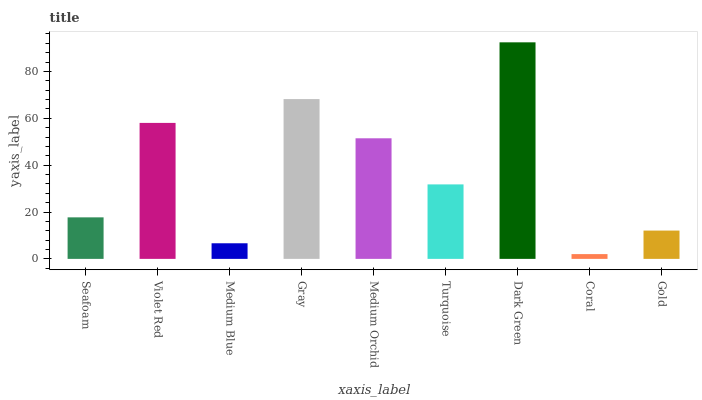Is Violet Red the minimum?
Answer yes or no. No. Is Violet Red the maximum?
Answer yes or no. No. Is Violet Red greater than Seafoam?
Answer yes or no. Yes. Is Seafoam less than Violet Red?
Answer yes or no. Yes. Is Seafoam greater than Violet Red?
Answer yes or no. No. Is Violet Red less than Seafoam?
Answer yes or no. No. Is Turquoise the high median?
Answer yes or no. Yes. Is Turquoise the low median?
Answer yes or no. Yes. Is Medium Blue the high median?
Answer yes or no. No. Is Gold the low median?
Answer yes or no. No. 